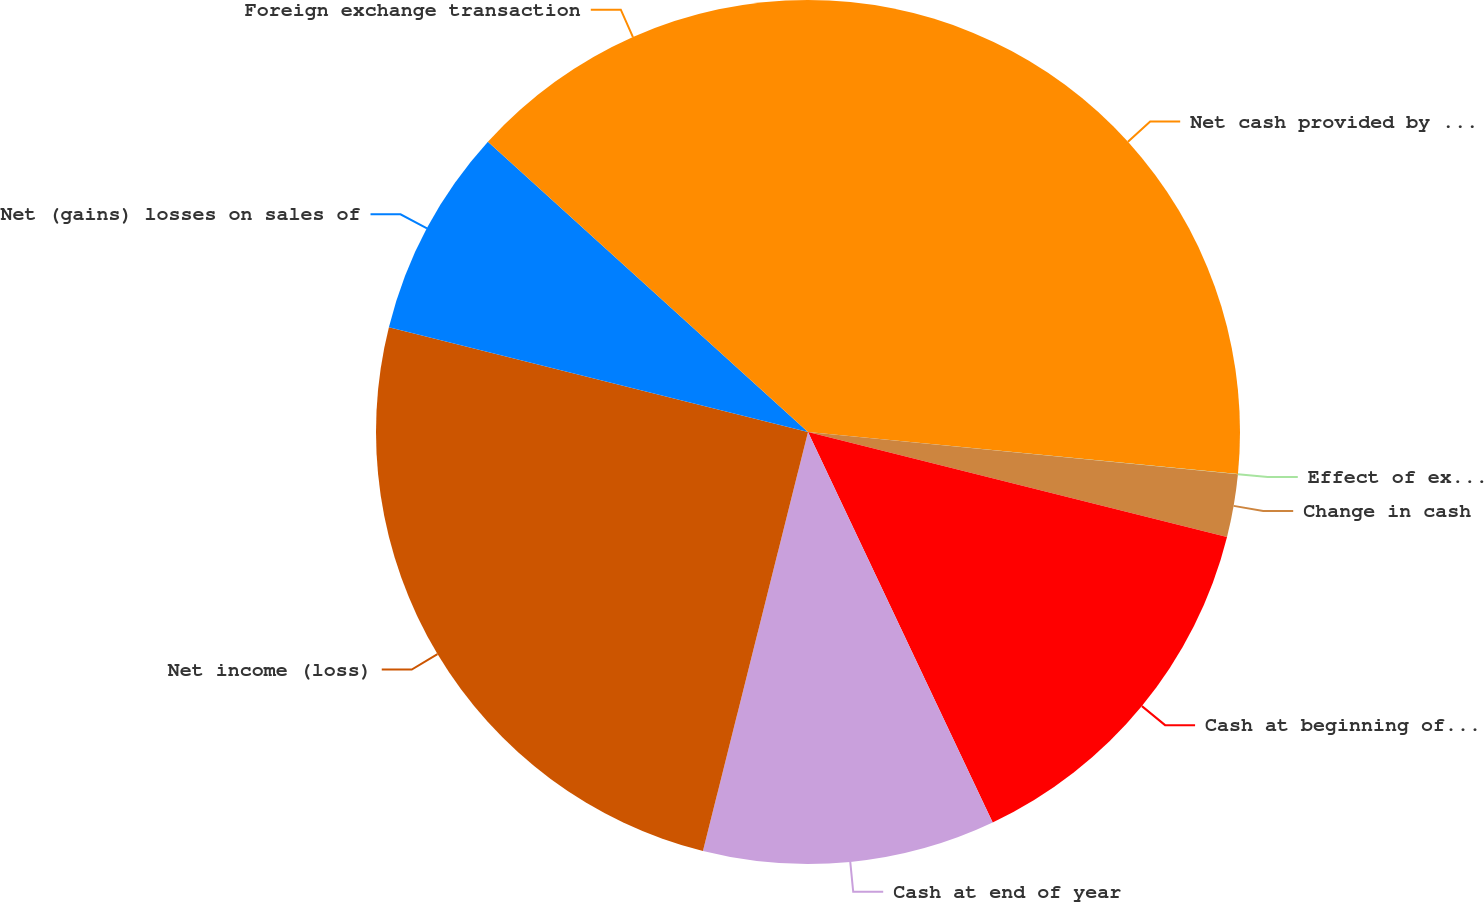<chart> <loc_0><loc_0><loc_500><loc_500><pie_chart><fcel>Net cash provided by (used in)<fcel>Effect of exchange rate<fcel>Change in cash<fcel>Cash at beginning of year<fcel>Cash at end of year<fcel>Net income (loss)<fcel>Net (gains) losses on sales of<fcel>Foreign exchange transaction<nl><fcel>26.55%<fcel>0.01%<fcel>2.35%<fcel>14.06%<fcel>10.94%<fcel>24.99%<fcel>7.82%<fcel>13.28%<nl></chart> 